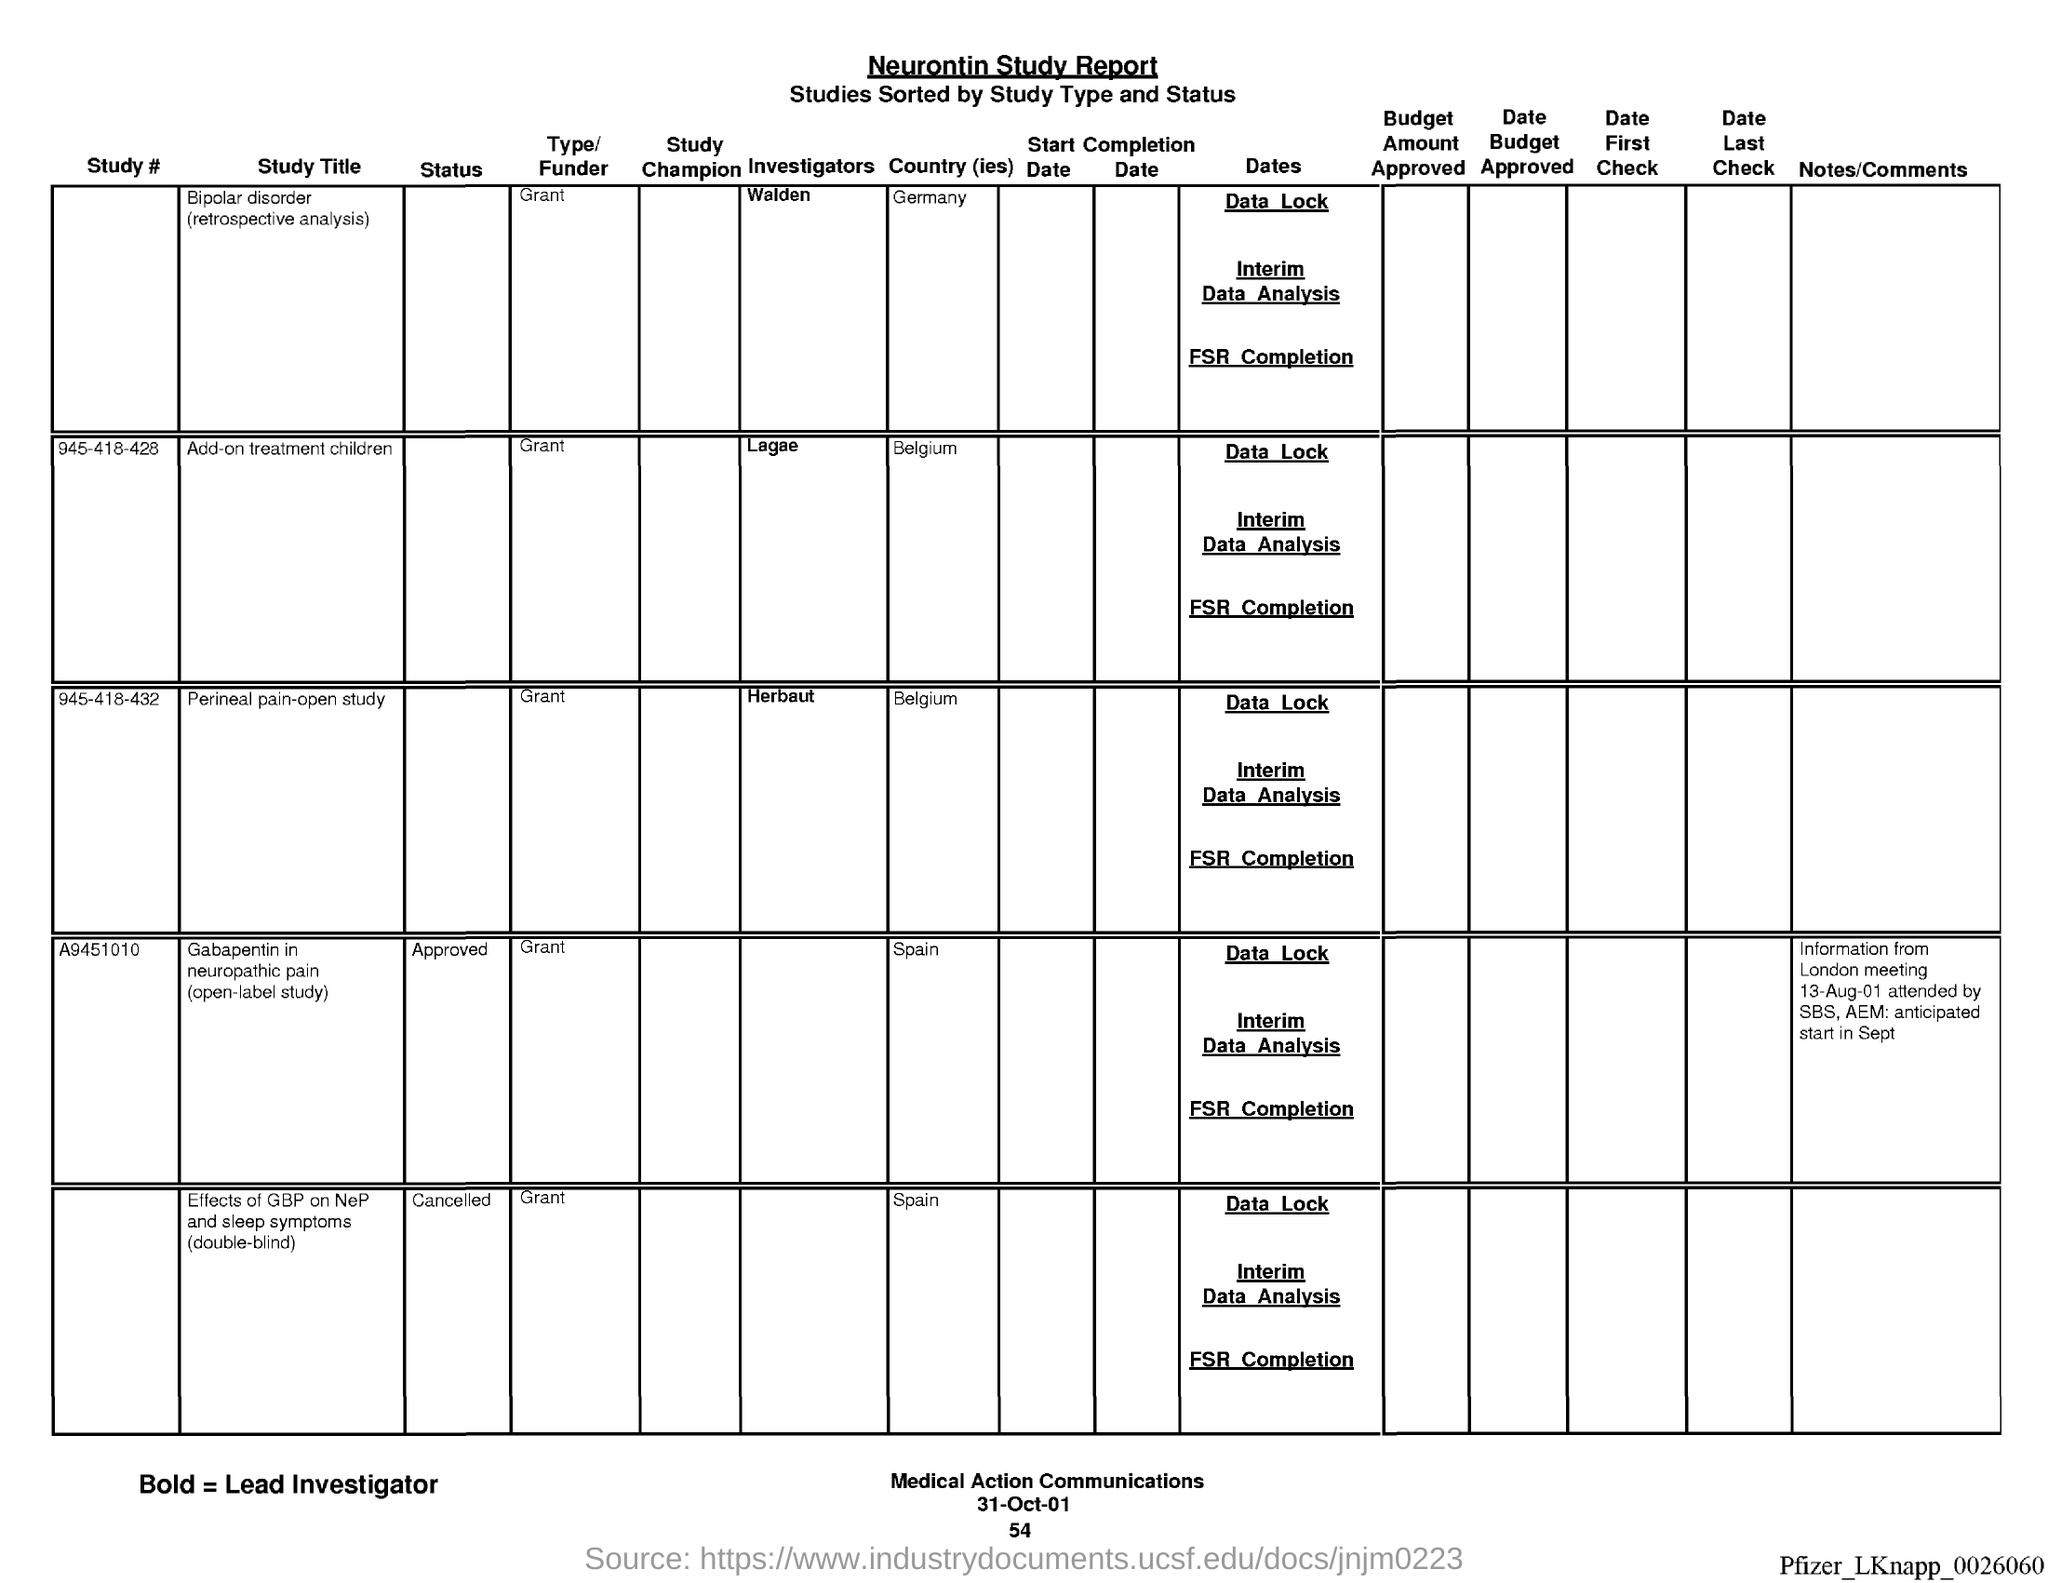What is the name of the report ?
Provide a succinct answer. Neurontin Study Report. What is the date at bottom of the page?
Your response must be concise. 31-Oct-01. What is the page number below date?
Offer a very short reply. 54. 